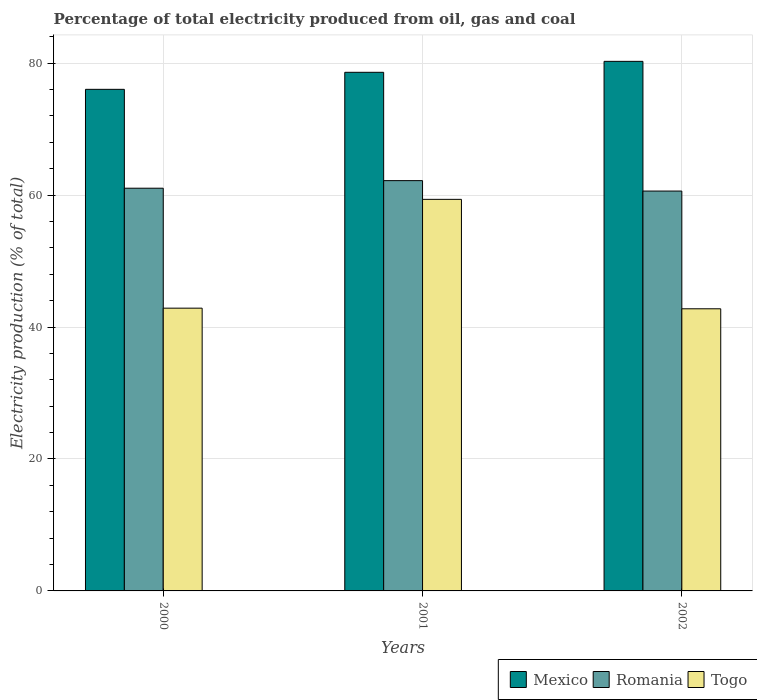How many groups of bars are there?
Make the answer very short. 3. Are the number of bars per tick equal to the number of legend labels?
Provide a succinct answer. Yes. Are the number of bars on each tick of the X-axis equal?
Offer a terse response. Yes. How many bars are there on the 1st tick from the left?
Offer a very short reply. 3. How many bars are there on the 2nd tick from the right?
Make the answer very short. 3. What is the label of the 1st group of bars from the left?
Offer a terse response. 2000. What is the electricity production in in Romania in 2000?
Make the answer very short. 61.04. Across all years, what is the maximum electricity production in in Togo?
Offer a very short reply. 59.35. Across all years, what is the minimum electricity production in in Romania?
Ensure brevity in your answer.  60.61. In which year was the electricity production in in Mexico maximum?
Keep it short and to the point. 2002. In which year was the electricity production in in Mexico minimum?
Your response must be concise. 2000. What is the total electricity production in in Romania in the graph?
Your answer should be compact. 183.83. What is the difference between the electricity production in in Togo in 2000 and that in 2001?
Keep it short and to the point. -16.49. What is the difference between the electricity production in in Togo in 2000 and the electricity production in in Romania in 2002?
Your response must be concise. -17.75. What is the average electricity production in in Togo per year?
Your answer should be compact. 48.32. In the year 2000, what is the difference between the electricity production in in Togo and electricity production in in Mexico?
Give a very brief answer. -33.17. In how many years, is the electricity production in in Mexico greater than 52 %?
Ensure brevity in your answer.  3. What is the ratio of the electricity production in in Togo in 2001 to that in 2002?
Offer a very short reply. 1.39. Is the difference between the electricity production in in Togo in 2000 and 2002 greater than the difference between the electricity production in in Mexico in 2000 and 2002?
Offer a very short reply. Yes. What is the difference between the highest and the second highest electricity production in in Togo?
Your response must be concise. 16.49. What is the difference between the highest and the lowest electricity production in in Romania?
Your response must be concise. 1.58. What does the 1st bar from the left in 2002 represents?
Your answer should be compact. Mexico. What does the 1st bar from the right in 2000 represents?
Your response must be concise. Togo. What is the difference between two consecutive major ticks on the Y-axis?
Offer a very short reply. 20. Does the graph contain any zero values?
Your answer should be compact. No. Does the graph contain grids?
Your response must be concise. Yes. What is the title of the graph?
Keep it short and to the point. Percentage of total electricity produced from oil, gas and coal. What is the label or title of the X-axis?
Your answer should be compact. Years. What is the label or title of the Y-axis?
Keep it short and to the point. Electricity production (% of total). What is the Electricity production (% of total) in Mexico in 2000?
Your answer should be very brief. 76.02. What is the Electricity production (% of total) in Romania in 2000?
Make the answer very short. 61.04. What is the Electricity production (% of total) of Togo in 2000?
Give a very brief answer. 42.86. What is the Electricity production (% of total) of Mexico in 2001?
Offer a very short reply. 78.61. What is the Electricity production (% of total) of Romania in 2001?
Offer a very short reply. 62.19. What is the Electricity production (% of total) of Togo in 2001?
Ensure brevity in your answer.  59.35. What is the Electricity production (% of total) in Mexico in 2002?
Give a very brief answer. 80.27. What is the Electricity production (% of total) of Romania in 2002?
Keep it short and to the point. 60.61. What is the Electricity production (% of total) in Togo in 2002?
Provide a short and direct response. 42.76. Across all years, what is the maximum Electricity production (% of total) in Mexico?
Your response must be concise. 80.27. Across all years, what is the maximum Electricity production (% of total) of Romania?
Keep it short and to the point. 62.19. Across all years, what is the maximum Electricity production (% of total) of Togo?
Ensure brevity in your answer.  59.35. Across all years, what is the minimum Electricity production (% of total) of Mexico?
Offer a very short reply. 76.02. Across all years, what is the minimum Electricity production (% of total) in Romania?
Give a very brief answer. 60.61. Across all years, what is the minimum Electricity production (% of total) of Togo?
Provide a short and direct response. 42.76. What is the total Electricity production (% of total) in Mexico in the graph?
Offer a terse response. 234.9. What is the total Electricity production (% of total) of Romania in the graph?
Offer a terse response. 183.83. What is the total Electricity production (% of total) in Togo in the graph?
Your answer should be compact. 144.97. What is the difference between the Electricity production (% of total) in Mexico in 2000 and that in 2001?
Keep it short and to the point. -2.58. What is the difference between the Electricity production (% of total) of Romania in 2000 and that in 2001?
Make the answer very short. -1.15. What is the difference between the Electricity production (% of total) in Togo in 2000 and that in 2001?
Your response must be concise. -16.49. What is the difference between the Electricity production (% of total) of Mexico in 2000 and that in 2002?
Offer a terse response. -4.24. What is the difference between the Electricity production (% of total) in Romania in 2000 and that in 2002?
Your answer should be very brief. 0.43. What is the difference between the Electricity production (% of total) of Togo in 2000 and that in 2002?
Give a very brief answer. 0.09. What is the difference between the Electricity production (% of total) in Mexico in 2001 and that in 2002?
Provide a short and direct response. -1.66. What is the difference between the Electricity production (% of total) in Romania in 2001 and that in 2002?
Make the answer very short. 1.58. What is the difference between the Electricity production (% of total) of Togo in 2001 and that in 2002?
Ensure brevity in your answer.  16.59. What is the difference between the Electricity production (% of total) in Mexico in 2000 and the Electricity production (% of total) in Romania in 2001?
Provide a short and direct response. 13.84. What is the difference between the Electricity production (% of total) in Mexico in 2000 and the Electricity production (% of total) in Togo in 2001?
Provide a short and direct response. 16.67. What is the difference between the Electricity production (% of total) in Romania in 2000 and the Electricity production (% of total) in Togo in 2001?
Ensure brevity in your answer.  1.69. What is the difference between the Electricity production (% of total) of Mexico in 2000 and the Electricity production (% of total) of Romania in 2002?
Offer a terse response. 15.42. What is the difference between the Electricity production (% of total) in Mexico in 2000 and the Electricity production (% of total) in Togo in 2002?
Your answer should be very brief. 33.26. What is the difference between the Electricity production (% of total) of Romania in 2000 and the Electricity production (% of total) of Togo in 2002?
Give a very brief answer. 18.28. What is the difference between the Electricity production (% of total) of Mexico in 2001 and the Electricity production (% of total) of Romania in 2002?
Your answer should be very brief. 18. What is the difference between the Electricity production (% of total) in Mexico in 2001 and the Electricity production (% of total) in Togo in 2002?
Provide a succinct answer. 35.84. What is the difference between the Electricity production (% of total) of Romania in 2001 and the Electricity production (% of total) of Togo in 2002?
Your response must be concise. 19.42. What is the average Electricity production (% of total) of Mexico per year?
Provide a short and direct response. 78.3. What is the average Electricity production (% of total) in Romania per year?
Offer a terse response. 61.28. What is the average Electricity production (% of total) in Togo per year?
Your answer should be compact. 48.32. In the year 2000, what is the difference between the Electricity production (% of total) of Mexico and Electricity production (% of total) of Romania?
Provide a short and direct response. 14.99. In the year 2000, what is the difference between the Electricity production (% of total) of Mexico and Electricity production (% of total) of Togo?
Your answer should be very brief. 33.17. In the year 2000, what is the difference between the Electricity production (% of total) in Romania and Electricity production (% of total) in Togo?
Keep it short and to the point. 18.18. In the year 2001, what is the difference between the Electricity production (% of total) of Mexico and Electricity production (% of total) of Romania?
Give a very brief answer. 16.42. In the year 2001, what is the difference between the Electricity production (% of total) of Mexico and Electricity production (% of total) of Togo?
Ensure brevity in your answer.  19.26. In the year 2001, what is the difference between the Electricity production (% of total) in Romania and Electricity production (% of total) in Togo?
Provide a succinct answer. 2.84. In the year 2002, what is the difference between the Electricity production (% of total) of Mexico and Electricity production (% of total) of Romania?
Your response must be concise. 19.66. In the year 2002, what is the difference between the Electricity production (% of total) in Mexico and Electricity production (% of total) in Togo?
Make the answer very short. 37.5. In the year 2002, what is the difference between the Electricity production (% of total) in Romania and Electricity production (% of total) in Togo?
Your answer should be very brief. 17.84. What is the ratio of the Electricity production (% of total) in Mexico in 2000 to that in 2001?
Make the answer very short. 0.97. What is the ratio of the Electricity production (% of total) of Romania in 2000 to that in 2001?
Make the answer very short. 0.98. What is the ratio of the Electricity production (% of total) in Togo in 2000 to that in 2001?
Keep it short and to the point. 0.72. What is the ratio of the Electricity production (% of total) in Mexico in 2000 to that in 2002?
Make the answer very short. 0.95. What is the ratio of the Electricity production (% of total) in Romania in 2000 to that in 2002?
Provide a succinct answer. 1.01. What is the ratio of the Electricity production (% of total) in Togo in 2000 to that in 2002?
Offer a very short reply. 1. What is the ratio of the Electricity production (% of total) in Mexico in 2001 to that in 2002?
Your answer should be compact. 0.98. What is the ratio of the Electricity production (% of total) in Romania in 2001 to that in 2002?
Offer a terse response. 1.03. What is the ratio of the Electricity production (% of total) of Togo in 2001 to that in 2002?
Offer a terse response. 1.39. What is the difference between the highest and the second highest Electricity production (% of total) of Mexico?
Offer a terse response. 1.66. What is the difference between the highest and the second highest Electricity production (% of total) of Romania?
Your answer should be compact. 1.15. What is the difference between the highest and the second highest Electricity production (% of total) in Togo?
Ensure brevity in your answer.  16.49. What is the difference between the highest and the lowest Electricity production (% of total) of Mexico?
Make the answer very short. 4.24. What is the difference between the highest and the lowest Electricity production (% of total) in Romania?
Ensure brevity in your answer.  1.58. What is the difference between the highest and the lowest Electricity production (% of total) of Togo?
Your answer should be very brief. 16.59. 